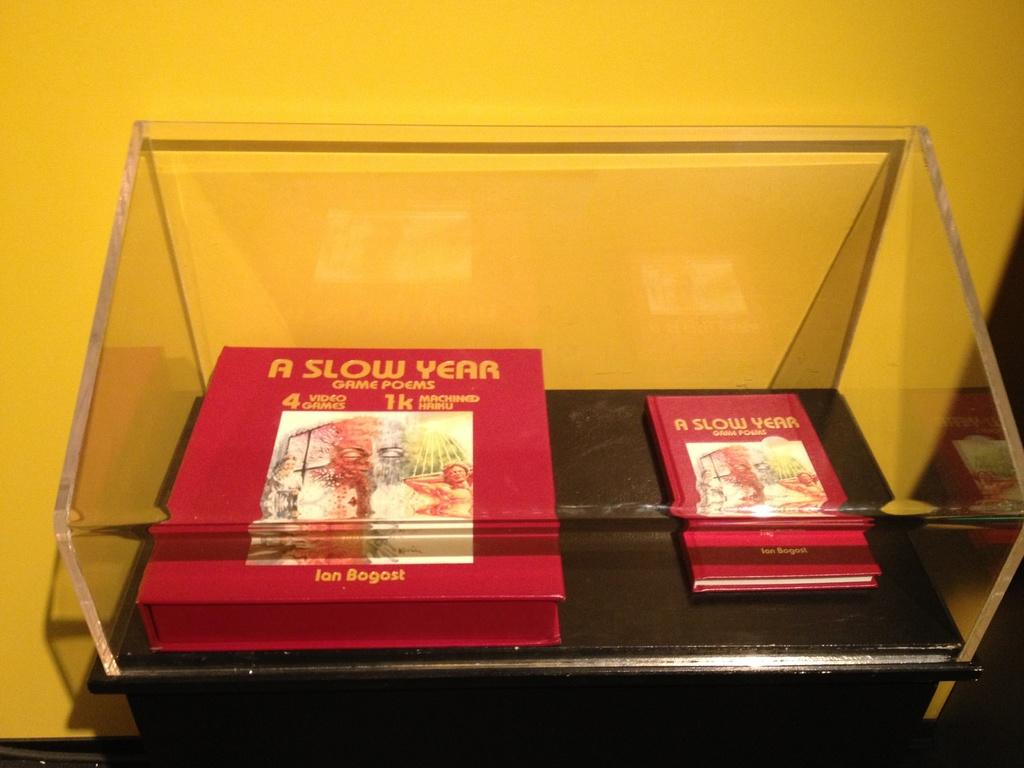<image>
Present a compact description of the photo's key features. Two books called "A Slow Year" are displayed under a protective shell. 